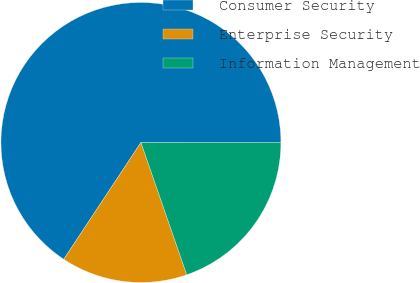<chart> <loc_0><loc_0><loc_500><loc_500><pie_chart><fcel>Consumer Security<fcel>Enterprise Security<fcel>Information Management<nl><fcel>65.69%<fcel>14.6%<fcel>19.71%<nl></chart> 